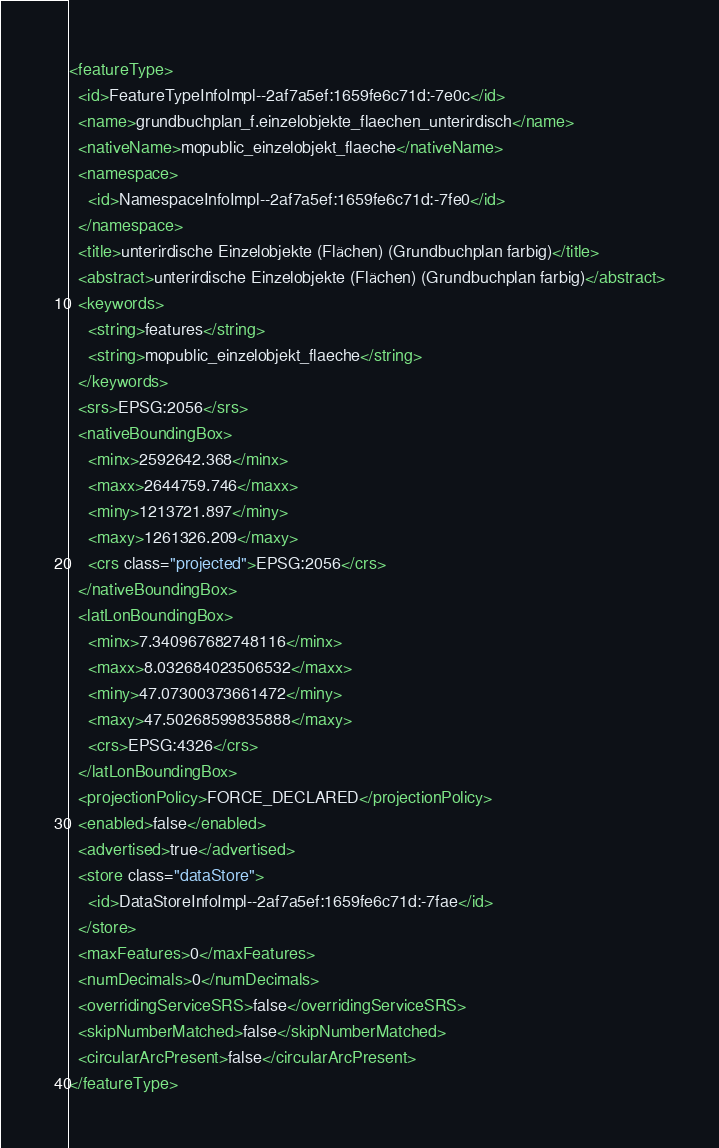Convert code to text. <code><loc_0><loc_0><loc_500><loc_500><_XML_><featureType>
  <id>FeatureTypeInfoImpl--2af7a5ef:1659fe6c71d:-7e0c</id>
  <name>grundbuchplan_f.einzelobjekte_flaechen_unterirdisch</name>
  <nativeName>mopublic_einzelobjekt_flaeche</nativeName>
  <namespace>
    <id>NamespaceInfoImpl--2af7a5ef:1659fe6c71d:-7fe0</id>
  </namespace>
  <title>unterirdische Einzelobjekte (Flächen) (Grundbuchplan farbig)</title>
  <abstract>unterirdische Einzelobjekte (Flächen) (Grundbuchplan farbig)</abstract>
  <keywords>
    <string>features</string>
    <string>mopublic_einzelobjekt_flaeche</string>
  </keywords>
  <srs>EPSG:2056</srs>
  <nativeBoundingBox>
    <minx>2592642.368</minx>
    <maxx>2644759.746</maxx>
    <miny>1213721.897</miny>
    <maxy>1261326.209</maxy>
    <crs class="projected">EPSG:2056</crs>
  </nativeBoundingBox>
  <latLonBoundingBox>
    <minx>7.340967682748116</minx>
    <maxx>8.032684023506532</maxx>
    <miny>47.07300373661472</miny>
    <maxy>47.50268599835888</maxy>
    <crs>EPSG:4326</crs>
  </latLonBoundingBox>
  <projectionPolicy>FORCE_DECLARED</projectionPolicy>
  <enabled>false</enabled>
  <advertised>true</advertised>
  <store class="dataStore">
    <id>DataStoreInfoImpl--2af7a5ef:1659fe6c71d:-7fae</id>
  </store>
  <maxFeatures>0</maxFeatures>
  <numDecimals>0</numDecimals>
  <overridingServiceSRS>false</overridingServiceSRS>
  <skipNumberMatched>false</skipNumberMatched>
  <circularArcPresent>false</circularArcPresent>
</featureType></code> 